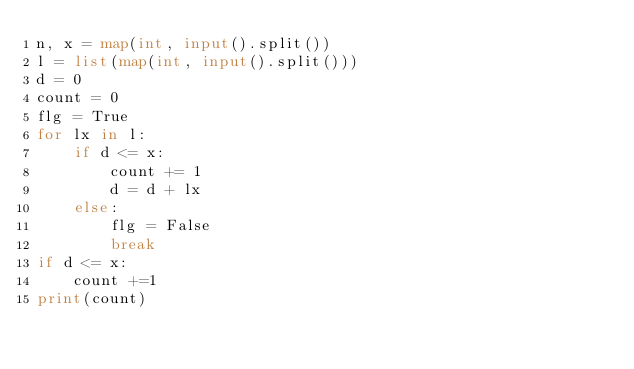Convert code to text. <code><loc_0><loc_0><loc_500><loc_500><_Python_>n, x = map(int, input().split())
l = list(map(int, input().split()))
d = 0
count = 0
flg = True
for lx in l:
    if d <= x:
        count += 1
        d = d + lx
    else:
        flg = False
        break
if d <= x:
    count +=1
print(count)</code> 